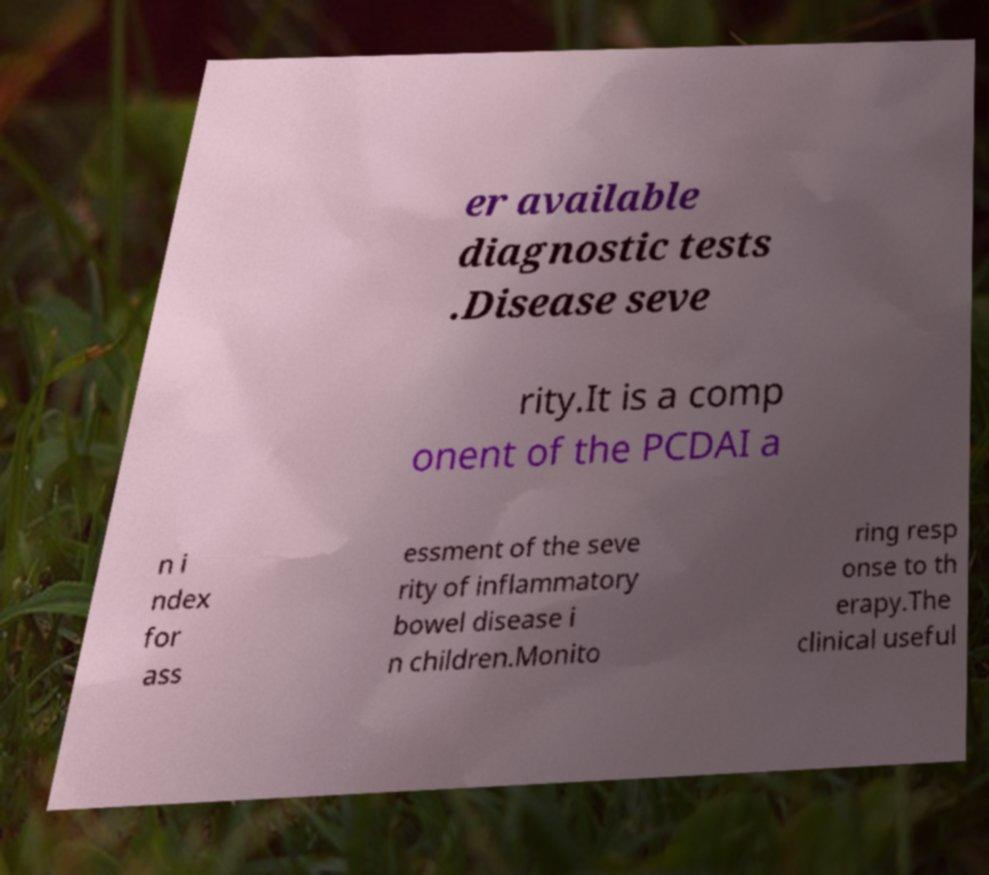Can you accurately transcribe the text from the provided image for me? er available diagnostic tests .Disease seve rity.It is a comp onent of the PCDAI a n i ndex for ass essment of the seve rity of inflammatory bowel disease i n children.Monito ring resp onse to th erapy.The clinical useful 